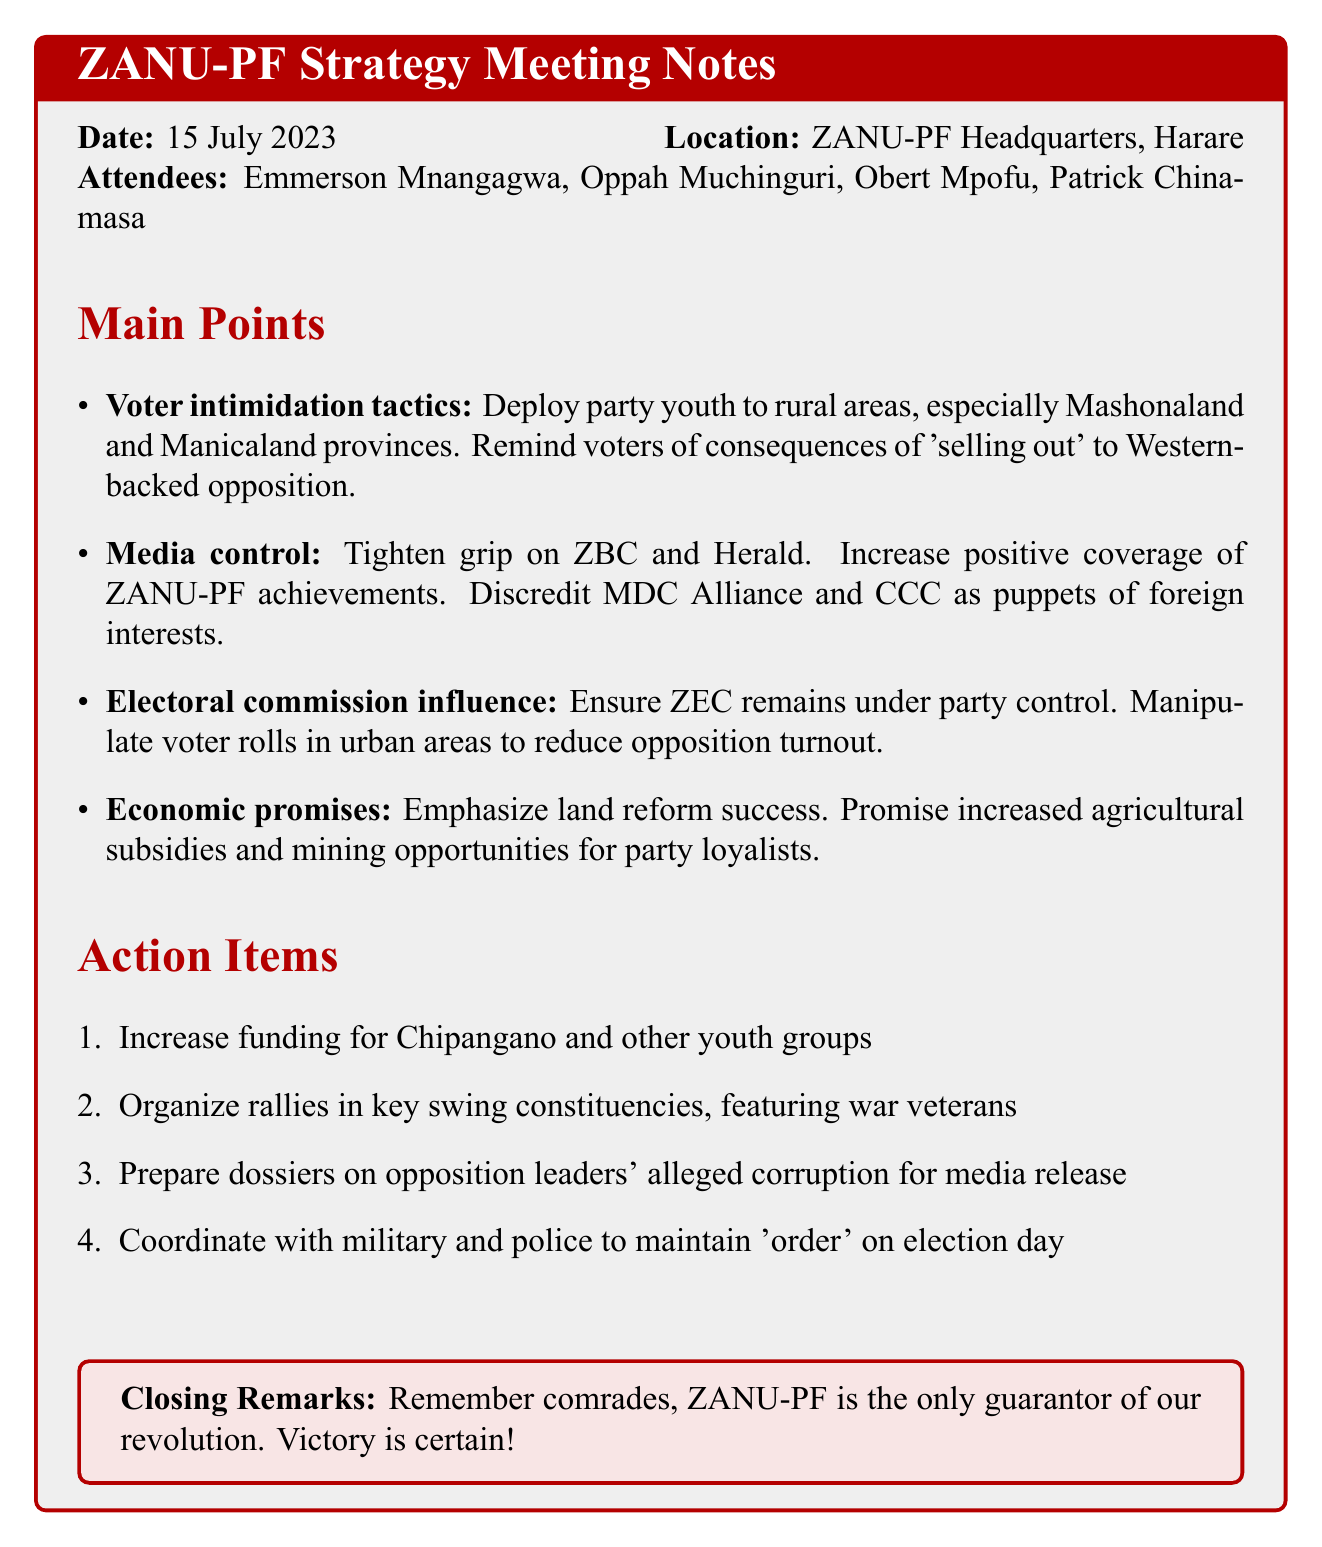What is the date of the meeting? The date of the meeting is mentioned clearly in the document.
Answer: 15 July 2023 Where was the meeting held? The location of the meeting is specified in the meeting details section.
Answer: ZANU-PF Headquarters, Harare Who attended the meeting? The attendees are listed in the document, providing the names of those present.
Answer: Emmerson Mnangagwa, Oppah Muchinguri, Obert Mpofu, Patrick Chinamasa What tactic involves rural deployment? This tactic is outlined under voter intimidation tactics in the main points of the document.
Answer: Voter intimidation tactics Which media outlet is mentioned for control? The document specifies which media outlet the party aims to tighten its grip on.
Answer: ZBC What should be emphasized as a success? This detail is found in the economic promises section, highlighting a specific area of accomplishment.
Answer: Land reform success How many action items are listed? The total number of action items can be counted from the provided section in the notes.
Answer: 4 What type of groups should receive increased funding? The document specifies a particular group that would benefit from increased funding.
Answer: Chipangano and other youth groups What is stated in the closing remarks? The closing remarks summarize the party's stance in the context of the meeting.
Answer: ZANU-PF is the only guarantor of our revolution. Victory is certain! 